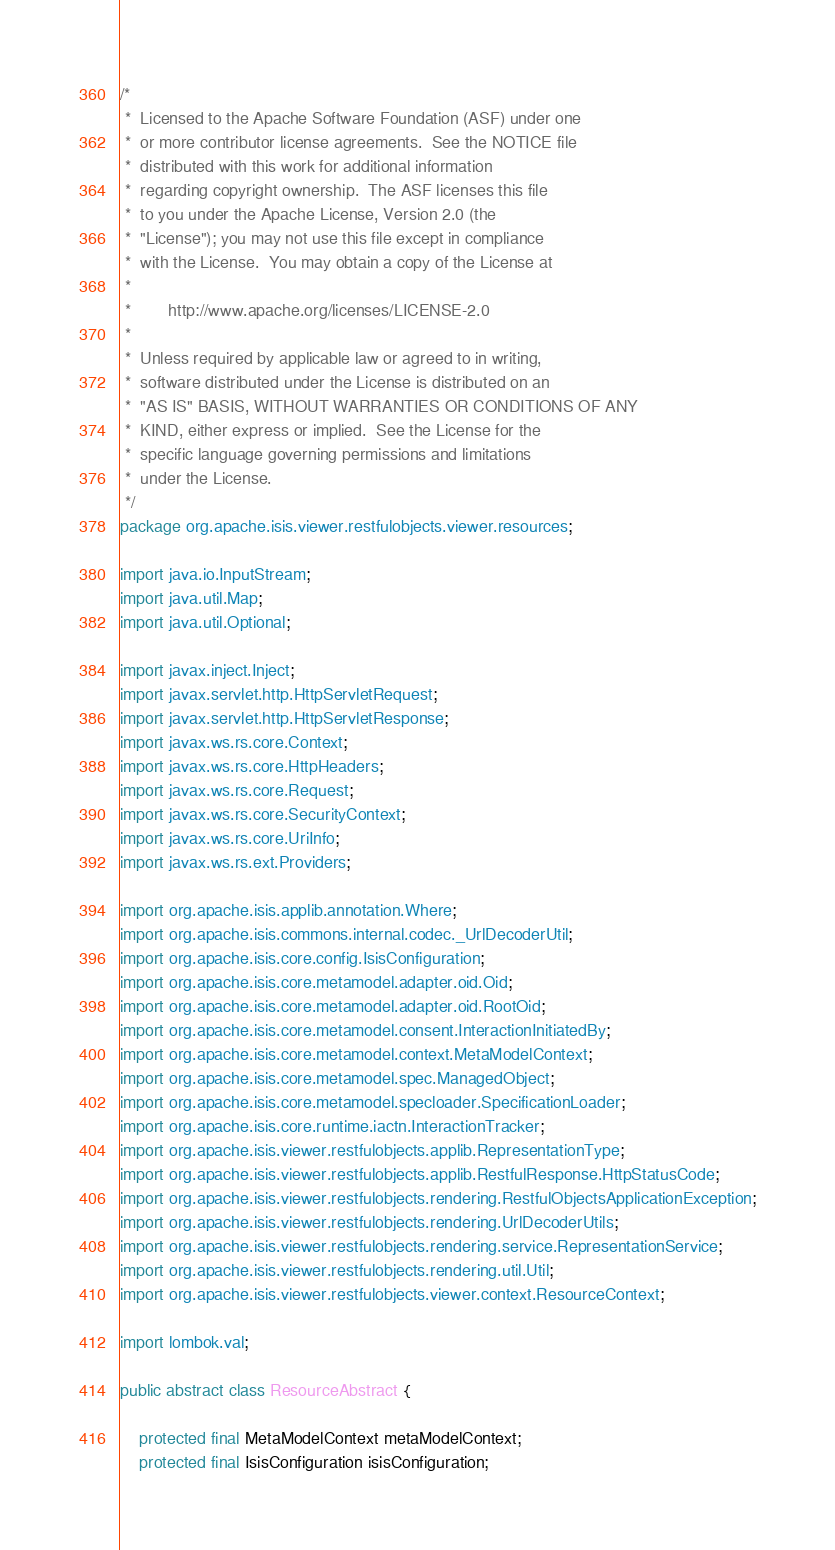Convert code to text. <code><loc_0><loc_0><loc_500><loc_500><_Java_>/*
 *  Licensed to the Apache Software Foundation (ASF) under one
 *  or more contributor license agreements.  See the NOTICE file
 *  distributed with this work for additional information
 *  regarding copyright ownership.  The ASF licenses this file
 *  to you under the Apache License, Version 2.0 (the
 *  "License"); you may not use this file except in compliance
 *  with the License.  You may obtain a copy of the License at
 *
 *        http://www.apache.org/licenses/LICENSE-2.0
 *
 *  Unless required by applicable law or agreed to in writing,
 *  software distributed under the License is distributed on an
 *  "AS IS" BASIS, WITHOUT WARRANTIES OR CONDITIONS OF ANY
 *  KIND, either express or implied.  See the License for the
 *  specific language governing permissions and limitations
 *  under the License.
 */
package org.apache.isis.viewer.restfulobjects.viewer.resources;

import java.io.InputStream;
import java.util.Map;
import java.util.Optional;

import javax.inject.Inject;
import javax.servlet.http.HttpServletRequest;
import javax.servlet.http.HttpServletResponse;
import javax.ws.rs.core.Context;
import javax.ws.rs.core.HttpHeaders;
import javax.ws.rs.core.Request;
import javax.ws.rs.core.SecurityContext;
import javax.ws.rs.core.UriInfo;
import javax.ws.rs.ext.Providers;

import org.apache.isis.applib.annotation.Where;
import org.apache.isis.commons.internal.codec._UrlDecoderUtil;
import org.apache.isis.core.config.IsisConfiguration;
import org.apache.isis.core.metamodel.adapter.oid.Oid;
import org.apache.isis.core.metamodel.adapter.oid.RootOid;
import org.apache.isis.core.metamodel.consent.InteractionInitiatedBy;
import org.apache.isis.core.metamodel.context.MetaModelContext;
import org.apache.isis.core.metamodel.spec.ManagedObject;
import org.apache.isis.core.metamodel.specloader.SpecificationLoader;
import org.apache.isis.core.runtime.iactn.InteractionTracker;
import org.apache.isis.viewer.restfulobjects.applib.RepresentationType;
import org.apache.isis.viewer.restfulobjects.applib.RestfulResponse.HttpStatusCode;
import org.apache.isis.viewer.restfulobjects.rendering.RestfulObjectsApplicationException;
import org.apache.isis.viewer.restfulobjects.rendering.UrlDecoderUtils;
import org.apache.isis.viewer.restfulobjects.rendering.service.RepresentationService;
import org.apache.isis.viewer.restfulobjects.rendering.util.Util;
import org.apache.isis.viewer.restfulobjects.viewer.context.ResourceContext;

import lombok.val;

public abstract class ResourceAbstract {

    protected final MetaModelContext metaModelContext;
    protected final IsisConfiguration isisConfiguration;</code> 